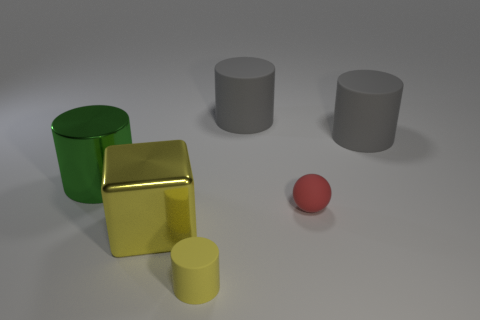Can you infer anything about the lighting in this scene? The image portrays diffused lighting with subtle shadows under each object, indicating a soft, possibly overhead light source. The reflections and highlights on the surfaces, especially the golden cube, suggest a controlled environment, possibly indicative of a studio setup. 